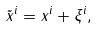<formula> <loc_0><loc_0><loc_500><loc_500>\tilde { x } ^ { i } = x ^ { i } + \xi ^ { i } ,</formula> 